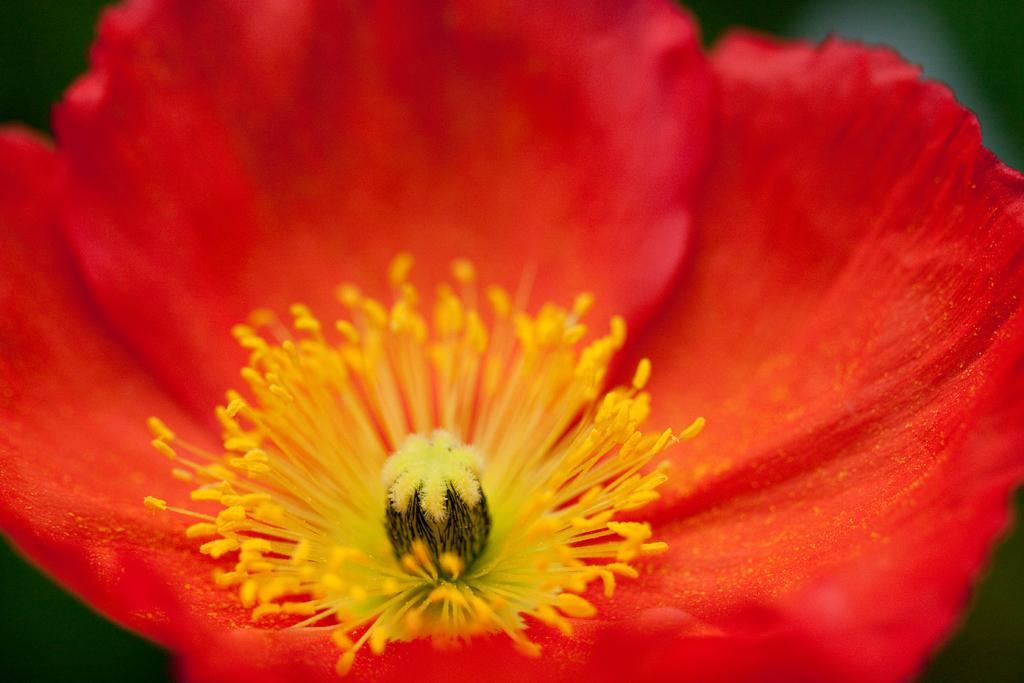In one or two sentences, can you explain what this image depicts? In the image in the center, we can see one flower, which is in red and yellow color. 